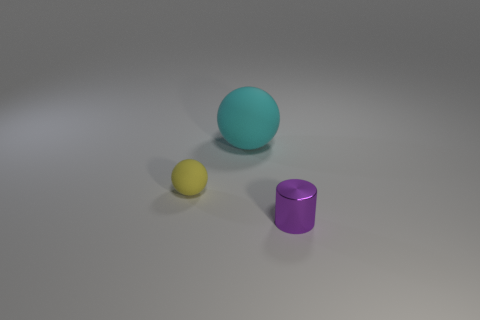Add 1 cyan matte cylinders. How many objects exist? 4 Subtract all cylinders. How many objects are left? 2 Add 2 yellow spheres. How many yellow spheres are left? 3 Add 2 big rubber balls. How many big rubber balls exist? 3 Subtract 0 blue cubes. How many objects are left? 3 Subtract all blue shiny balls. Subtract all metallic cylinders. How many objects are left? 2 